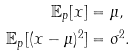<formula> <loc_0><loc_0><loc_500><loc_500>\mathbb { E } _ { p } [ x ] & = \mu , \\ \mathbb { E } _ { p } [ ( x - \mu ) ^ { 2 } ] & = \sigma ^ { 2 } .</formula> 